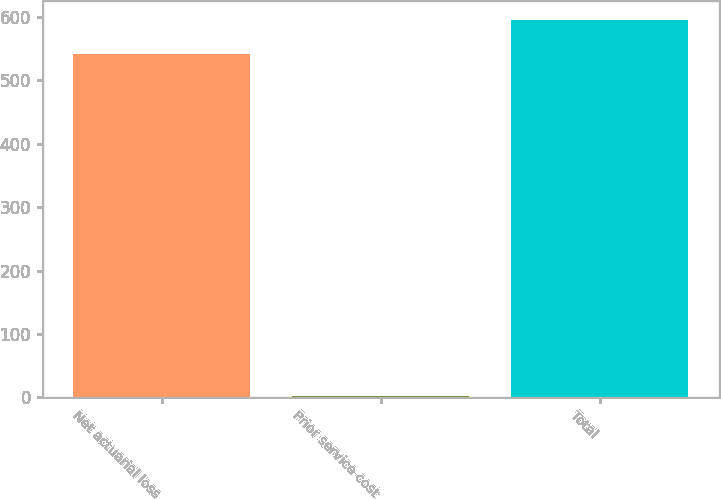Convert chart. <chart><loc_0><loc_0><loc_500><loc_500><bar_chart><fcel>Net actuarial loss<fcel>Prior service cost<fcel>Total<nl><fcel>541.8<fcel>1.4<fcel>596.02<nl></chart> 